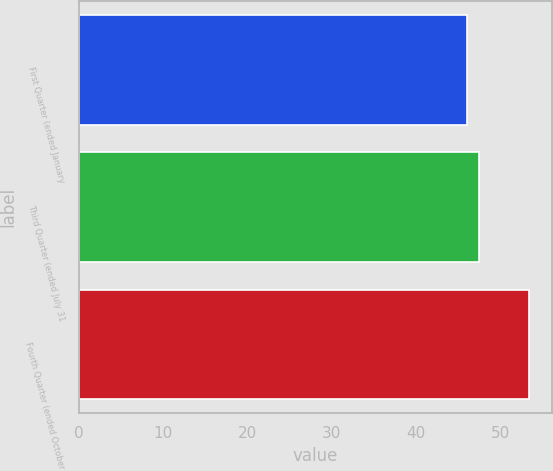Convert chart. <chart><loc_0><loc_0><loc_500><loc_500><bar_chart><fcel>First Quarter (ended January<fcel>Third Quarter (ended July 31<fcel>Fourth Quarter (ended October<nl><fcel>46.1<fcel>47.47<fcel>53.47<nl></chart> 